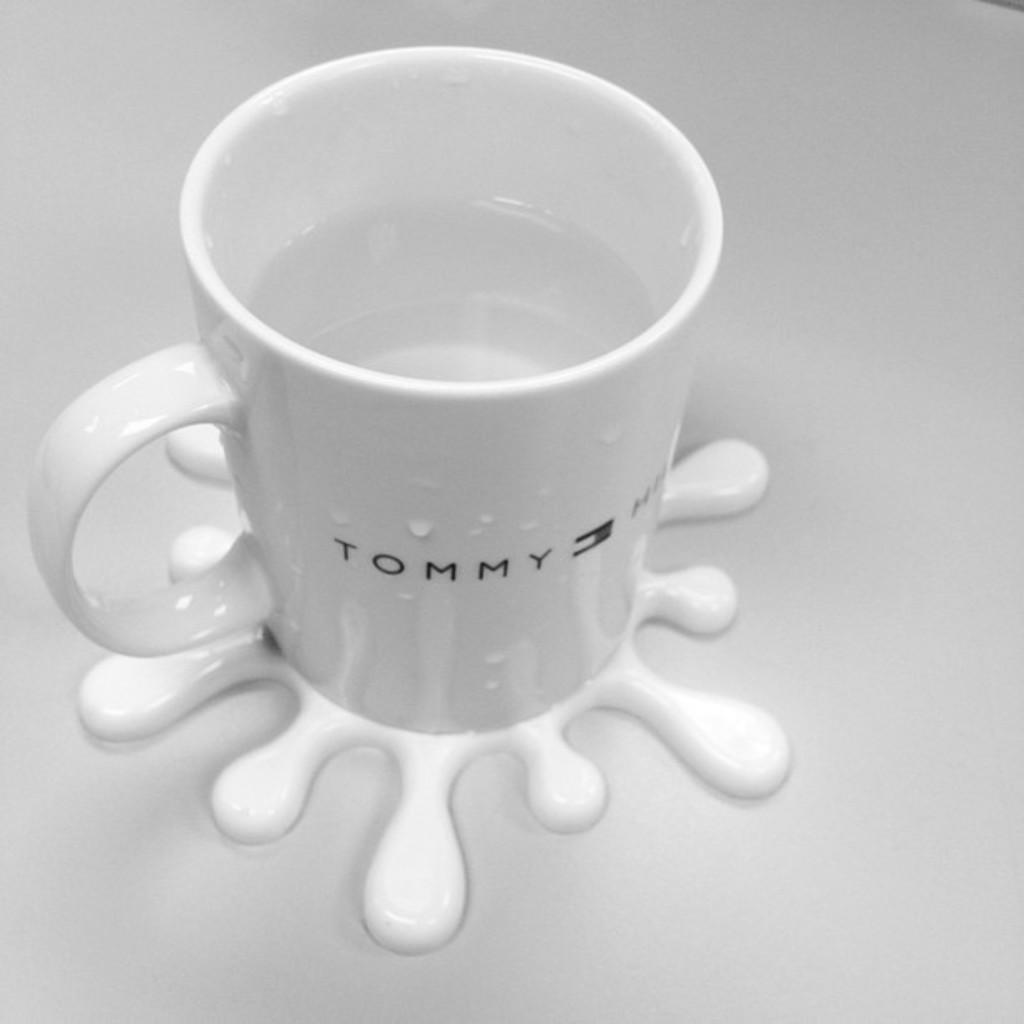Could you give a brief overview of what you see in this image? In this image I can see a cup which is white in color with water in it and I can see it is on the white colored surface. 